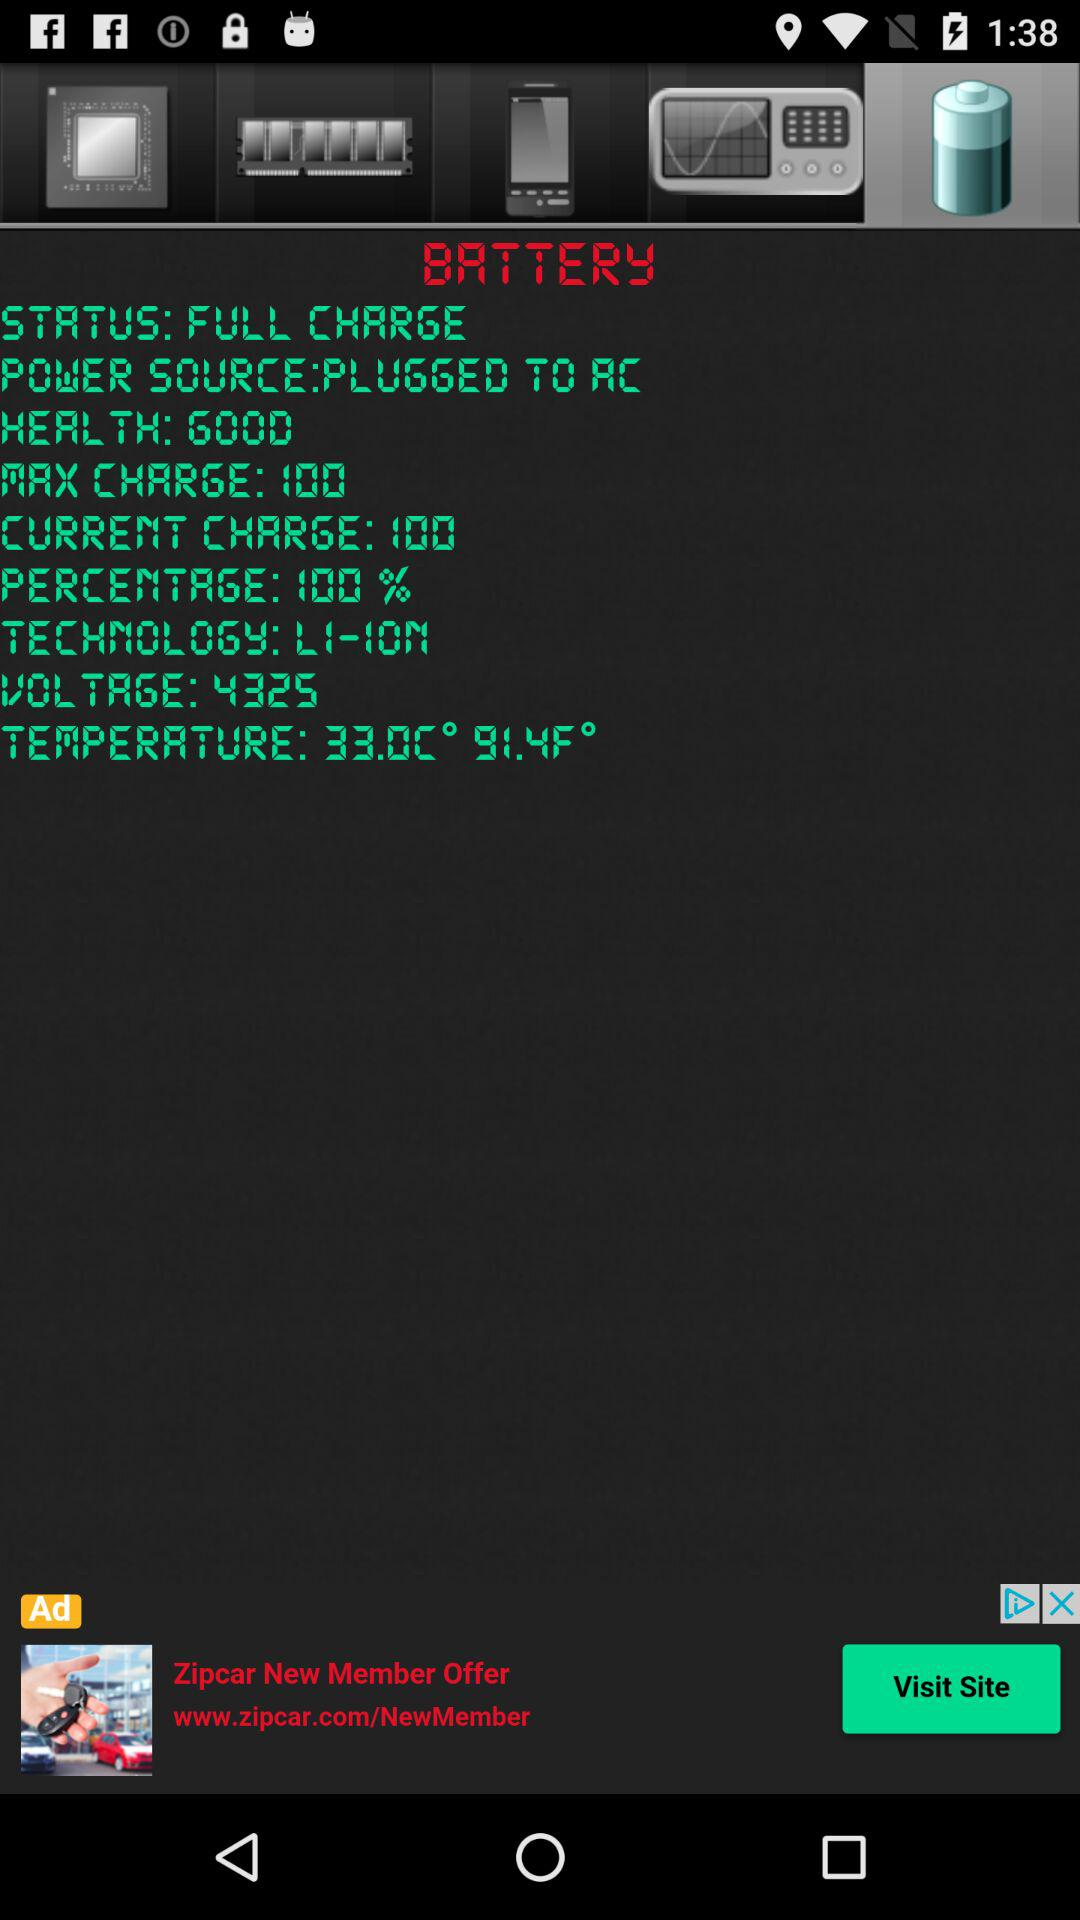What is the voltage? The voltage is 4325. 